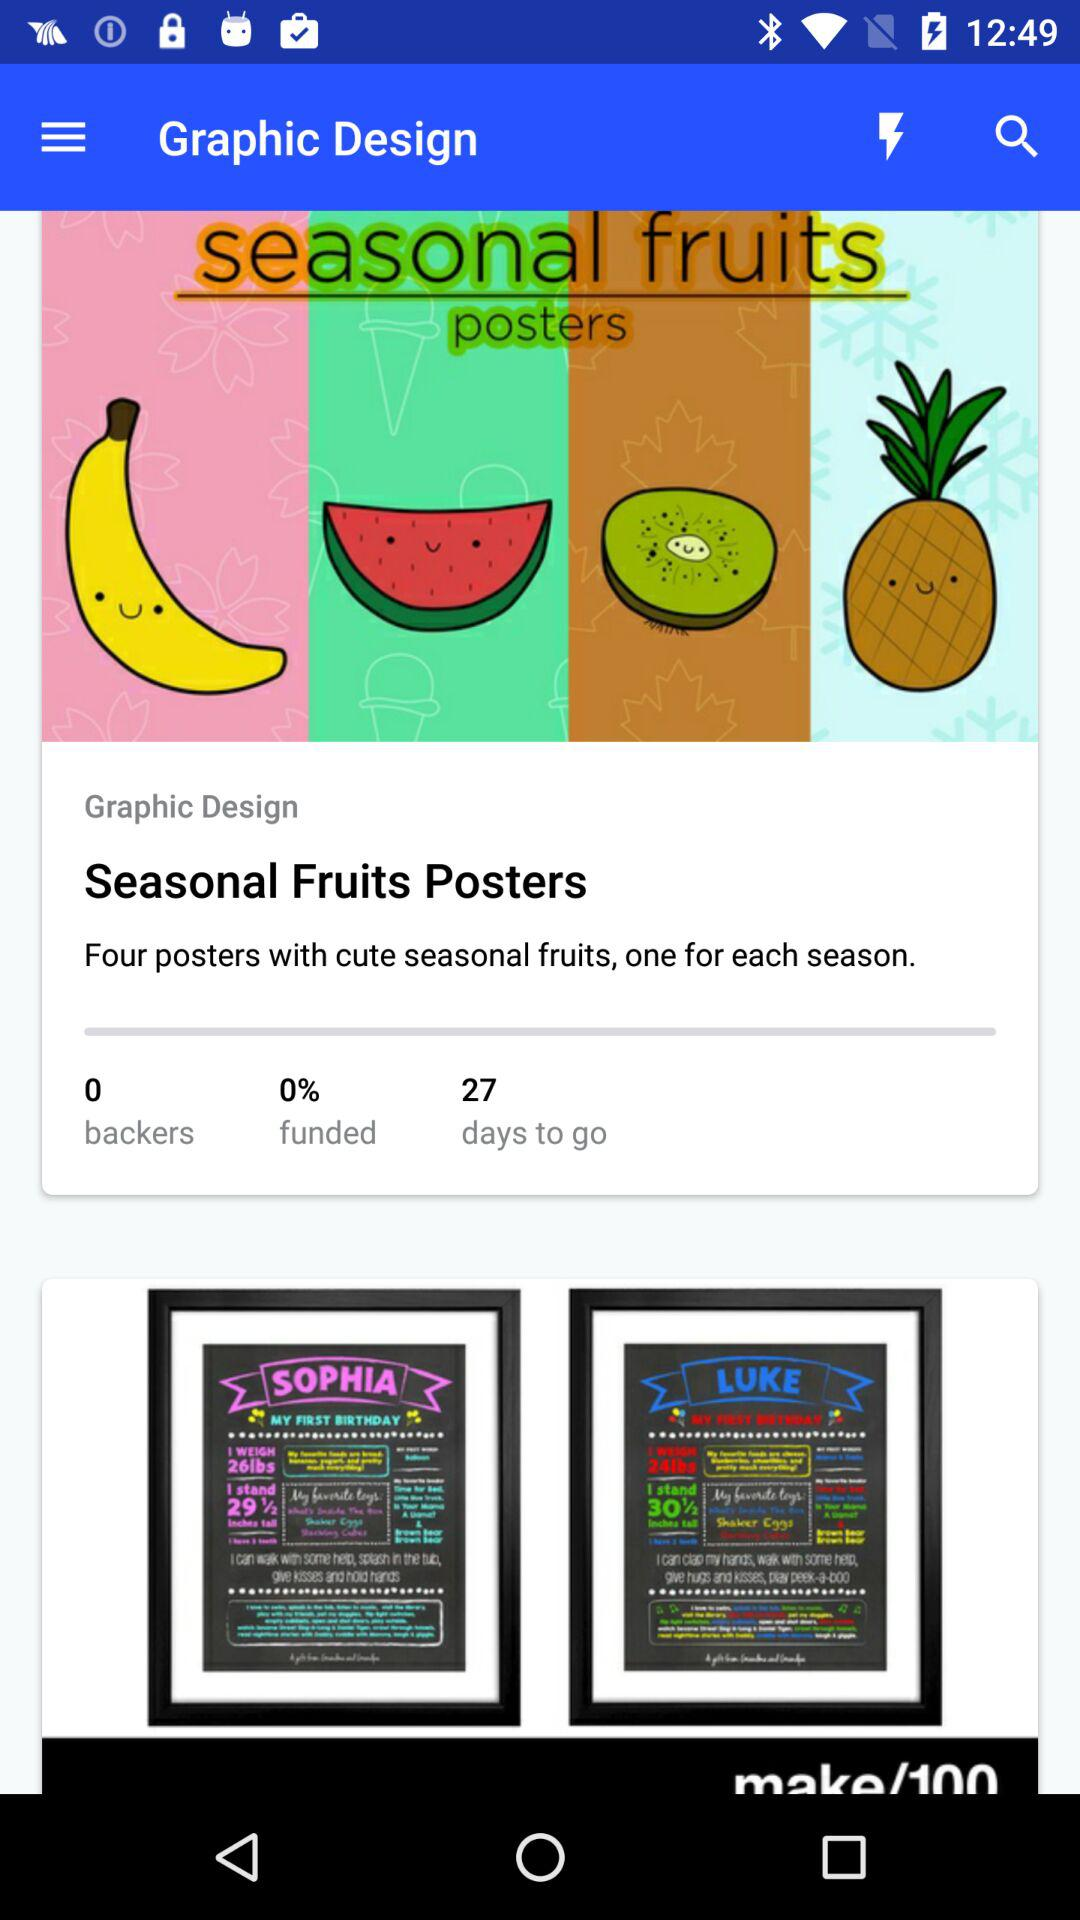What is the title of the graphic designed?
Answer the question using a single word or phrase. The title of graphic is seasonal fruites posters 